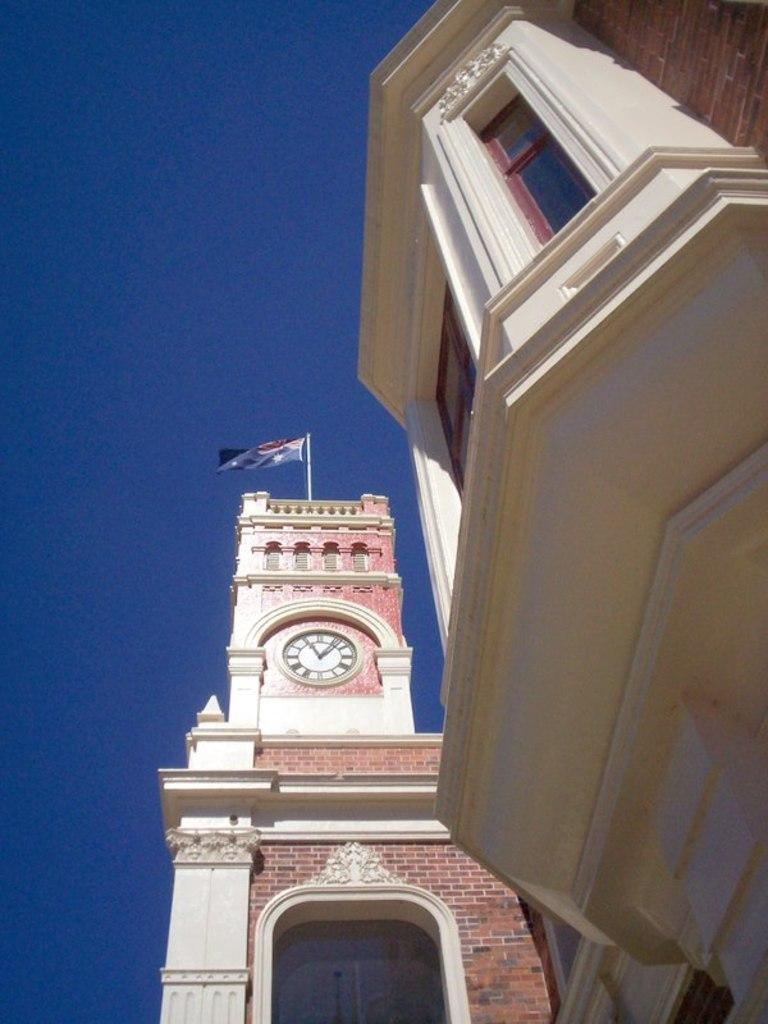What type of structures are present in the image? The image contains buildings. Can you describe the appearance of one of the buildings? The building has a brick wall. What feature is present on the building? The building has a clock. What is located at the top of the building? There is a flag at the top of the building. How would you describe the weather in the image? The sky is sunny in the image. What type of alarm is going off in the image? There is no alarm going off in the image. How does the growth of the building compare to other buildings in the image? There is only one building mentioned in the image, so it cannot be compared to other buildings in terms of growth. 